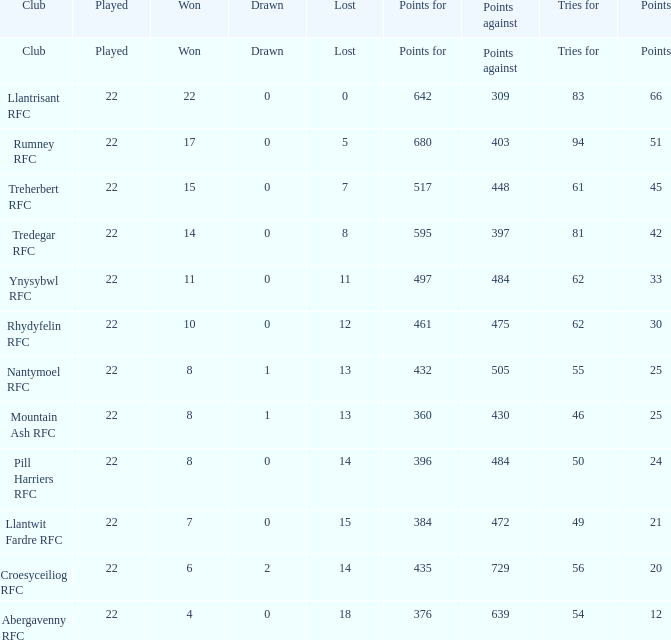Write the full table. {'header': ['Club', 'Played', 'Won', 'Drawn', 'Lost', 'Points for', 'Points against', 'Tries for', 'Points'], 'rows': [['Club', 'Played', 'Won', 'Drawn', 'Lost', 'Points for', 'Points against', 'Tries for', 'Points'], ['Llantrisant RFC', '22', '22', '0', '0', '642', '309', '83', '66'], ['Rumney RFC', '22', '17', '0', '5', '680', '403', '94', '51'], ['Treherbert RFC', '22', '15', '0', '7', '517', '448', '61', '45'], ['Tredegar RFC', '22', '14', '0', '8', '595', '397', '81', '42'], ['Ynysybwl RFC', '22', '11', '0', '11', '497', '484', '62', '33'], ['Rhydyfelin RFC', '22', '10', '0', '12', '461', '475', '62', '30'], ['Nantymoel RFC', '22', '8', '1', '13', '432', '505', '55', '25'], ['Mountain Ash RFC', '22', '8', '1', '13', '360', '430', '46', '25'], ['Pill Harriers RFC', '22', '8', '0', '14', '396', '484', '50', '24'], ['Llantwit Fardre RFC', '22', '7', '0', '15', '384', '472', '49', '21'], ['Croesyceiliog RFC', '22', '6', '2', '14', '435', '729', '56', '20'], ['Abergavenny RFC', '22', '4', '0', '18', '376', '639', '54', '12']]} What was the total score of the team that achieved exactly 22 victories? 642.0. 